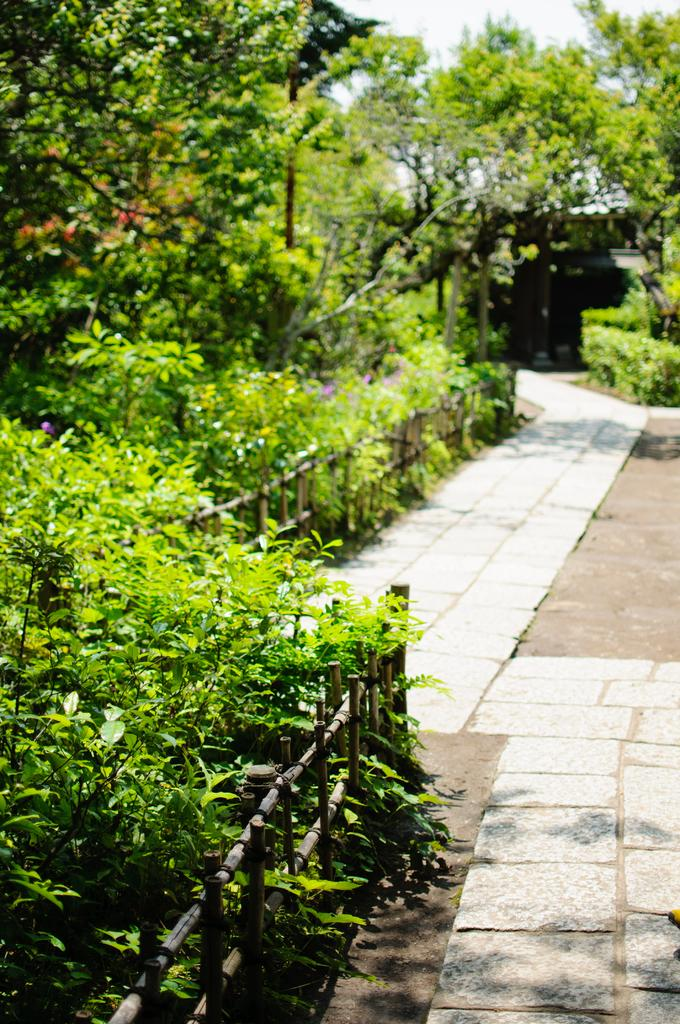What type of surface can be seen in the image? There is ground visible in the image. What feature is present in the image that might be used for walking? There is a path in the image. What structure is present in the image that might provide support or safety? There is a railing in the image. What type of vegetation is present on both sides of the path? There are trees on both sides of the path. What color are the trees in the image? The trees are green in color. What is visible in the background of the image? The sky is visible in the background of the image. What word is written on the mine in the image? There is no mine present in the image, so there is no word to be read. 